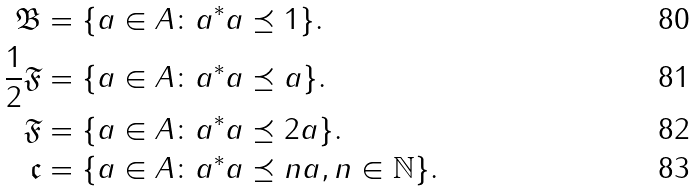Convert formula to latex. <formula><loc_0><loc_0><loc_500><loc_500>\mathfrak { B } & = \{ a \in A \colon a ^ { * } a \preceq 1 \} . \\ \frac { 1 } { 2 } \mathfrak { F } & = \{ a \in A \colon a ^ { * } a \preceq a \} . \\ \mathfrak { F } & = \{ a \in A \colon a ^ { * } a \preceq 2 a \} . \\ \mathfrak { c } & = \{ a \in A \colon a ^ { * } a \preceq n a , n \in \mathbb { N } \} .</formula> 